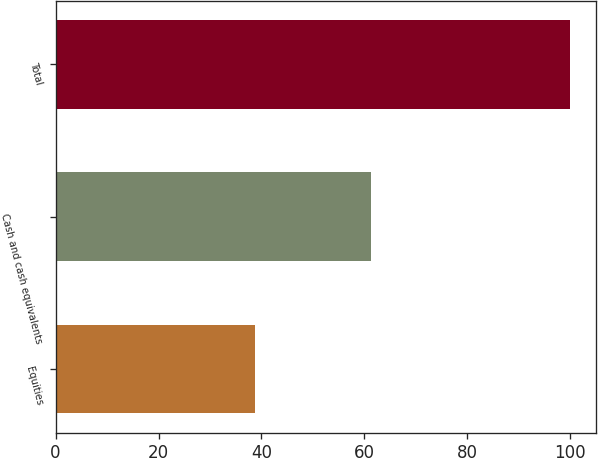<chart> <loc_0><loc_0><loc_500><loc_500><bar_chart><fcel>Equities<fcel>Cash and cash equivalents<fcel>Total<nl><fcel>38.8<fcel>61.2<fcel>100<nl></chart> 